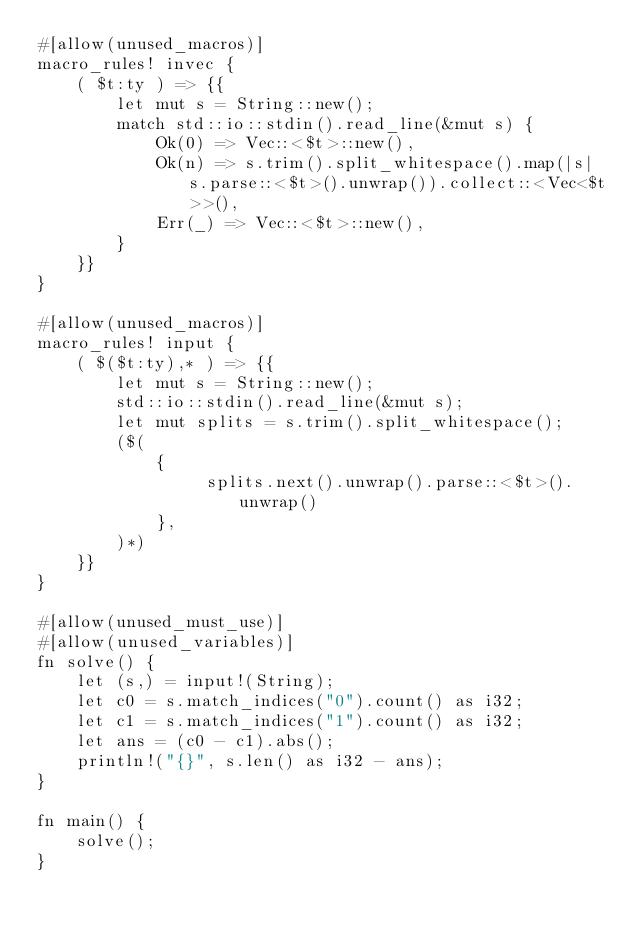Convert code to text. <code><loc_0><loc_0><loc_500><loc_500><_Rust_>#[allow(unused_macros)]
macro_rules! invec {
    ( $t:ty ) => {{
        let mut s = String::new();
        match std::io::stdin().read_line(&mut s) {
            Ok(0) => Vec::<$t>::new(),
            Ok(n) => s.trim().split_whitespace().map(|s| s.parse::<$t>().unwrap()).collect::<Vec<$t>>(),
            Err(_) => Vec::<$t>::new(),
        }
    }}
}

#[allow(unused_macros)]
macro_rules! input {
    ( $($t:ty),* ) => {{
        let mut s = String::new();
        std::io::stdin().read_line(&mut s);
        let mut splits = s.trim().split_whitespace();
        ($(
            {
                 splits.next().unwrap().parse::<$t>().unwrap()
            },
        )*)
    }}
}

#[allow(unused_must_use)]
#[allow(unused_variables)]
fn solve() {
    let (s,) = input!(String);
    let c0 = s.match_indices("0").count() as i32;
    let c1 = s.match_indices("1").count() as i32;
    let ans = (c0 - c1).abs();
    println!("{}", s.len() as i32 - ans);
}

fn main() {
    solve();
}
</code> 